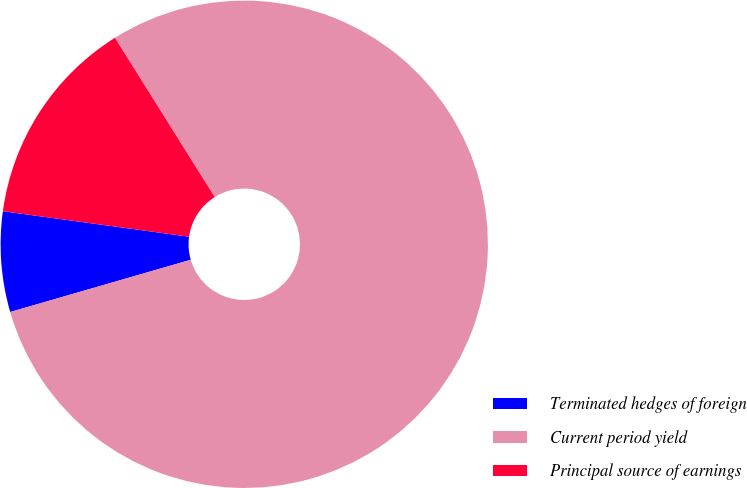<chart> <loc_0><loc_0><loc_500><loc_500><pie_chart><fcel>Terminated hedges of foreign<fcel>Current period yield<fcel>Principal source of earnings<nl><fcel>6.65%<fcel>79.43%<fcel>13.93%<nl></chart> 